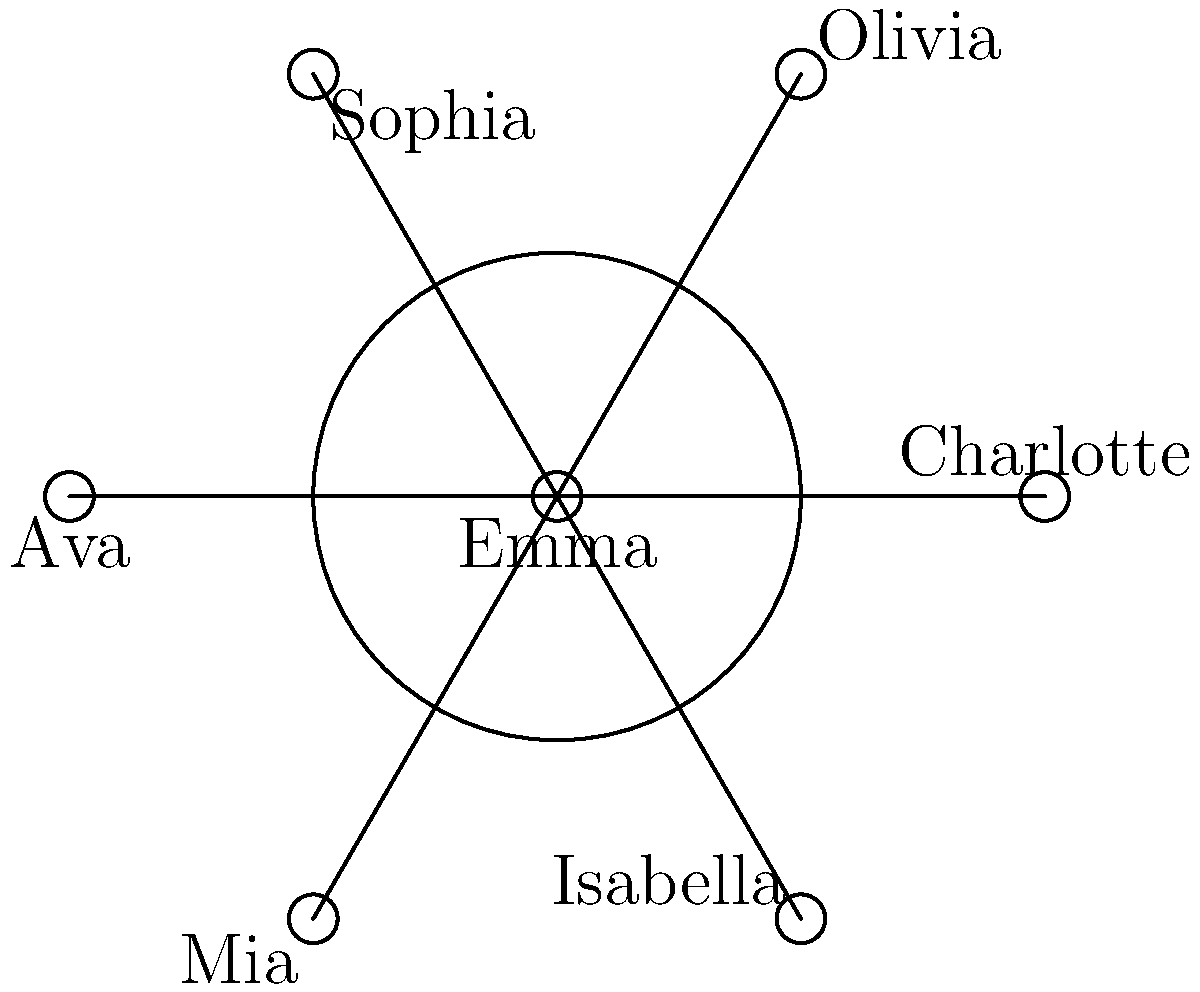In a contemporary fiction novel about love and relationships, the main character Emma is connected to six other characters in a social network. The connections are represented using a polar graph, where Emma is at the center and the other characters are equally spaced around her. If the angle between each character is $60^\circ$, what is the polar coordinate $(r, \theta)$ for the character Sophia, assuming the radius of the circle is 2 units and Olivia is at $\theta = 60^\circ$? To solve this problem, let's follow these steps:

1. Understand the graph structure:
   - Emma is at the center (0, 0)
   - The radius of the circle is 2 units
   - There are 6 characters equally spaced around Emma
   - The angle between each character is $60^\circ$

2. Identify Olivia's position:
   - Olivia is given to be at $\theta = 60^\circ$

3. Determine Sophia's position:
   - Sophia is the second character clockwise from Olivia
   - This means Sophia is at an angle of $60^\circ + (2 * 60^\circ) = 180^\circ$

4. Express Sophia's position in polar coordinates:
   - The radius $r$ is given as 2 units
   - The angle $\theta$ is $180^\circ$

5. Write the final polar coordinate:
   - Sophia's position is $(r, \theta) = (2, 180^\circ)$

This representation allows us to precisely locate Sophia in the social network graph, showcasing her relationship to Emma and the other characters in the novel's ensemble.
Answer: $(2, 180^\circ)$ 